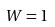Convert formula to latex. <formula><loc_0><loc_0><loc_500><loc_500>W = 1</formula> 